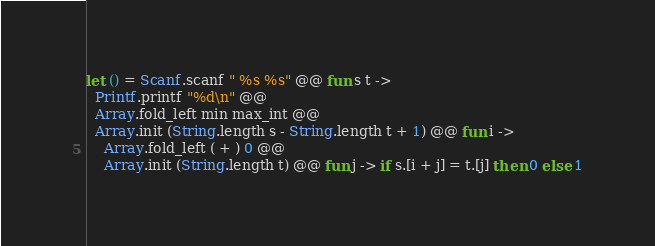Convert code to text. <code><loc_0><loc_0><loc_500><loc_500><_OCaml_>let () = Scanf.scanf " %s %s" @@ fun s t ->
  Printf.printf "%d\n" @@
  Array.fold_left min max_int @@
  Array.init (String.length s - String.length t + 1) @@ fun i ->
    Array.fold_left ( + ) 0 @@
    Array.init (String.length t) @@ fun j -> if s.[i + j] = t.[j] then 0 else 1</code> 